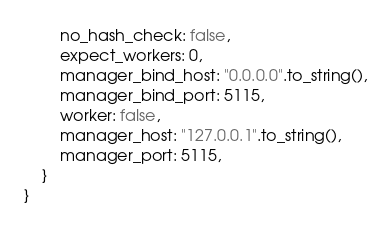Convert code to text. <code><loc_0><loc_0><loc_500><loc_500><_Rust_>        no_hash_check: false,
        expect_workers: 0,
        manager_bind_host: "0.0.0.0".to_string(),
        manager_bind_port: 5115,
        worker: false,
        manager_host: "127.0.0.1".to_string(),
        manager_port: 5115,
    }
}
</code> 